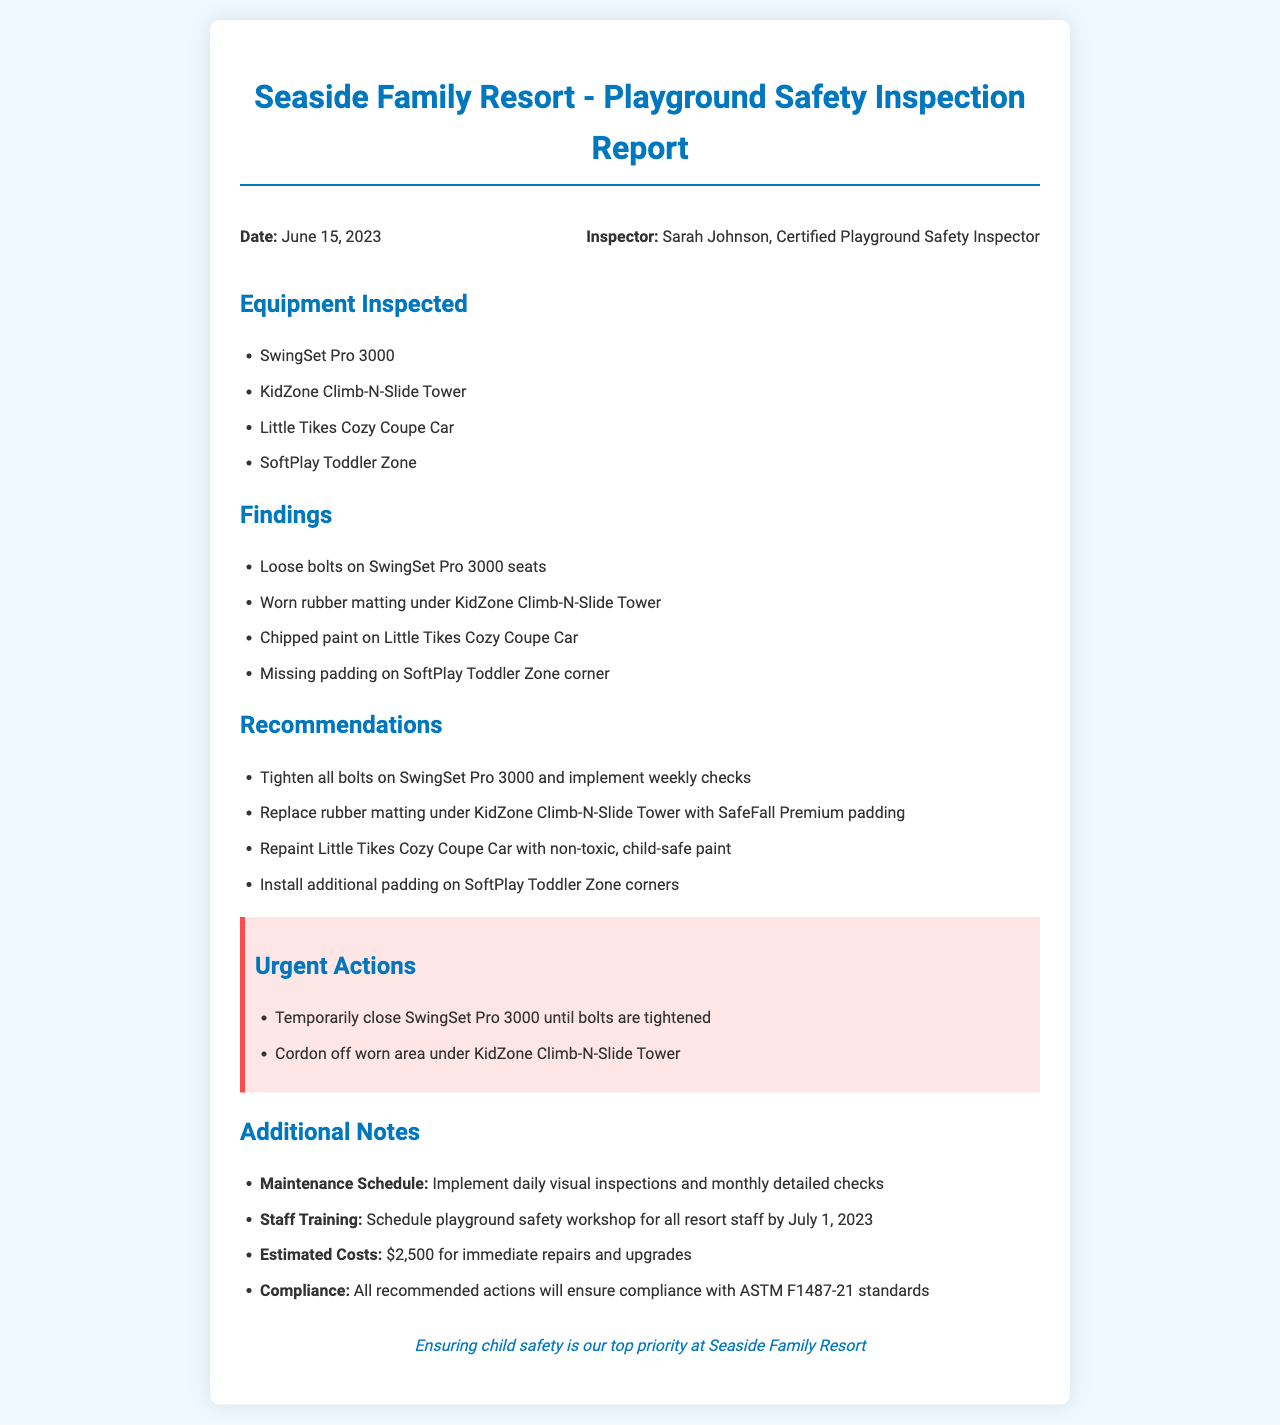what is the date of the inspection? The inspection date is mentioned at the beginning of the report as June 15, 2023.
Answer: June 15, 2023 who conducted the inspection? The name of the inspector is provided in the document as Sarah Johnson, Certified Playground Safety Inspector.
Answer: Sarah Johnson what is one urgent action required? The report lists urgent actions, including temporarily closing the SwingSet Pro 3000 until bolts are tightened.
Answer: Temporarily close SwingSet Pro 3000 how many pieces of equipment were inspected? The document lists four pieces of playground equipment inspected.
Answer: Four what is the estimated cost for immediate repairs? The report mentions an estimated cost of $2,500 for the necessary repairs and upgrades.
Answer: $2,500 what type of paint is recommended for the Little Tikes Cozy Coupe Car? The recommendations include repainting with non-toxic, child-safe paint.
Answer: Non-toxic, child-safe paint what kind of training is suggested for resort staff? The report recommends scheduling a playground safety workshop for all resort staff.
Answer: Playground safety workshop what compliance standard is mentioned in the report? The document states compliance with ASTM F1487-21 standards.
Answer: ASTM F1487-21 